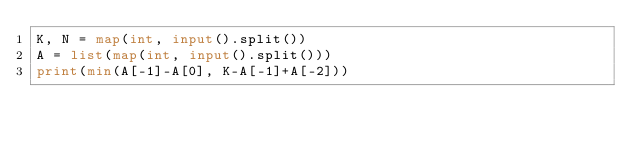Convert code to text. <code><loc_0><loc_0><loc_500><loc_500><_Python_>K, N = map(int, input().split())
A = list(map(int, input().split()))
print(min(A[-1]-A[0], K-A[-1]+A[-2]))</code> 